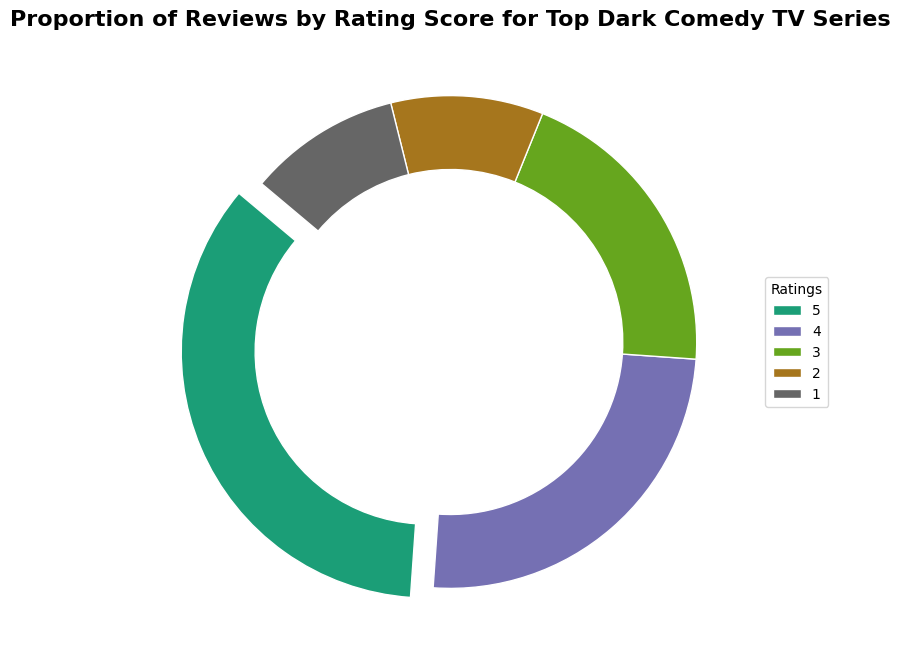What rating has the highest proportion of reviews? The largest slice of the pie chart is the one that is slightly exploded outward. This slice corresponds to the rating of 5, which takes up 35% of the pie chart.
Answer: Rating 5 What is the combined proportion of reviews for ratings 1 and 2? The slice for rating 1 represents 10% of reviews, and the slice for rating 2 represents another 10%. The combined proportion is 10% + 10%.
Answer: 20% Which rating has a smaller proportion: rating 3 or rating 4? The slice for rating 3 is smaller than the slice for rating 4. Rating 3 takes up 20%, while rating 4 takes up 25%.
Answer: Rating 3 What is the total proportion of reviews for ratings 3, 4, and 5? The slices collectively represent 20% for rating 3, 25% for rating 4, and 35% for rating 5. Adding up these proportions results in 20% + 25% + 35%.
Answer: 80% What proportion of reviews is at least a rating of 4? The slices for ratings 4 and 5 represent 25% and 35% respectively. Adding these gives 25% + 35%.
Answer: 60% What color is used to represent the highest rating in the chart? The highest rating, which is 5, is associated with the largest exploded slice in the pie chart. This slice is colored distinctly, typically in a visually prominent or first-used color in the Dark2 color scheme, such as a greenish hue.
Answer: Greenish hue 